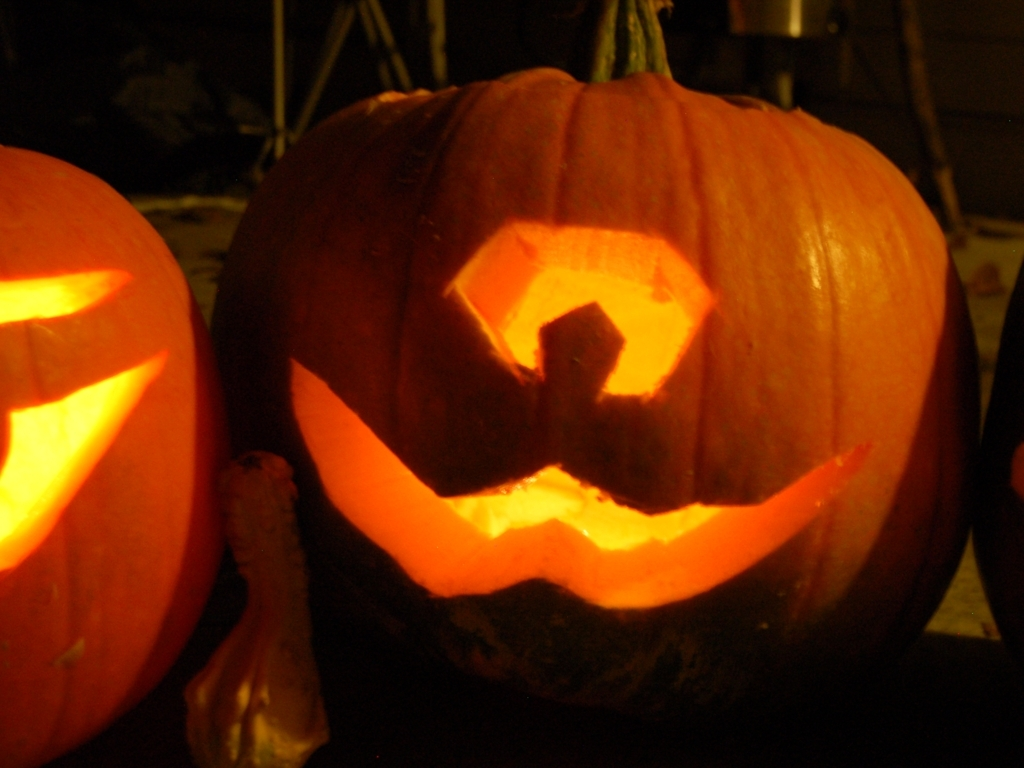How could someone recreate this pumpkin carving at home? To recreate this carving, one would select a pumpkin and use appropriate tools to hollow it out, design the face on the surface, and then carefully cut out the features. Placing a candle or light inside will give it the glowing effect seen in the image. 